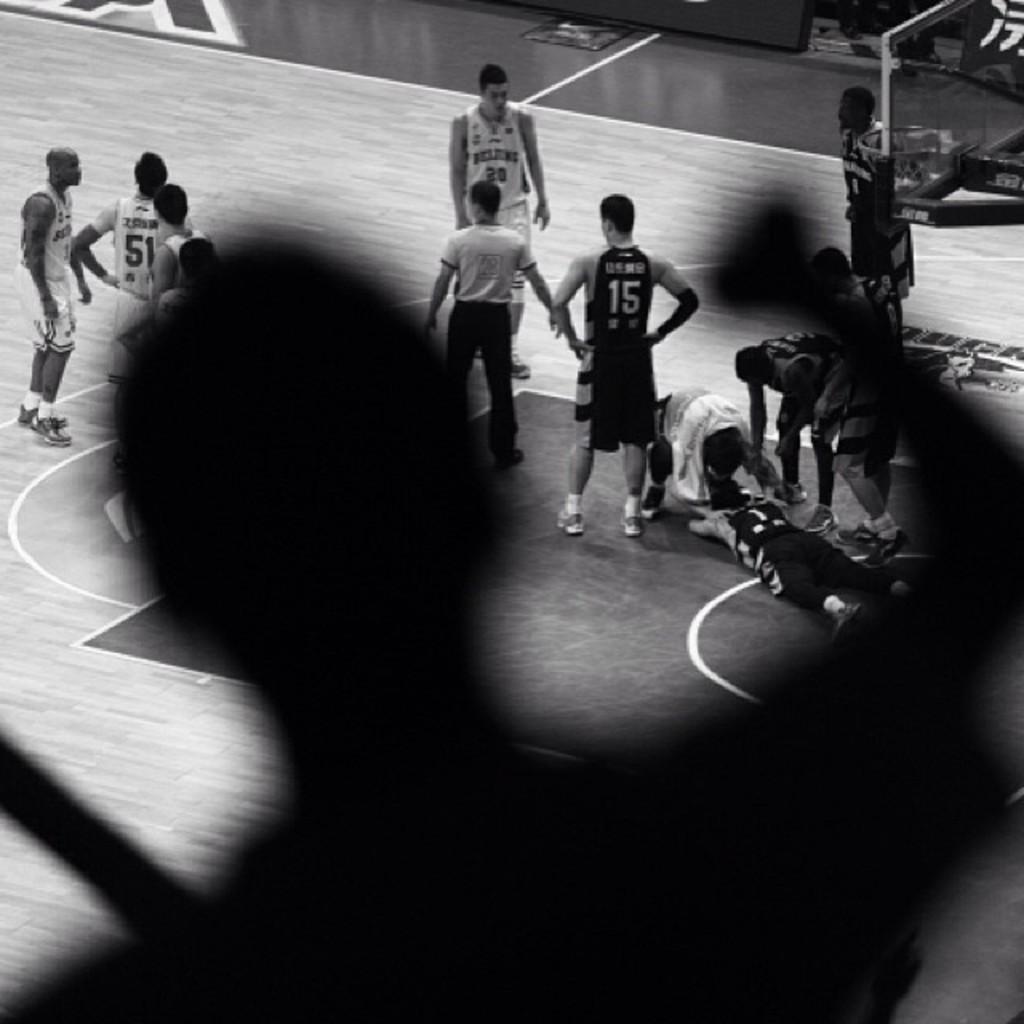Can you describe this image briefly? In this picture we can see basketball players who are standing on this pitch. Here we can see a man who is standing on the stadium. These players are wearing same dress. In the middle there is an umpire. 